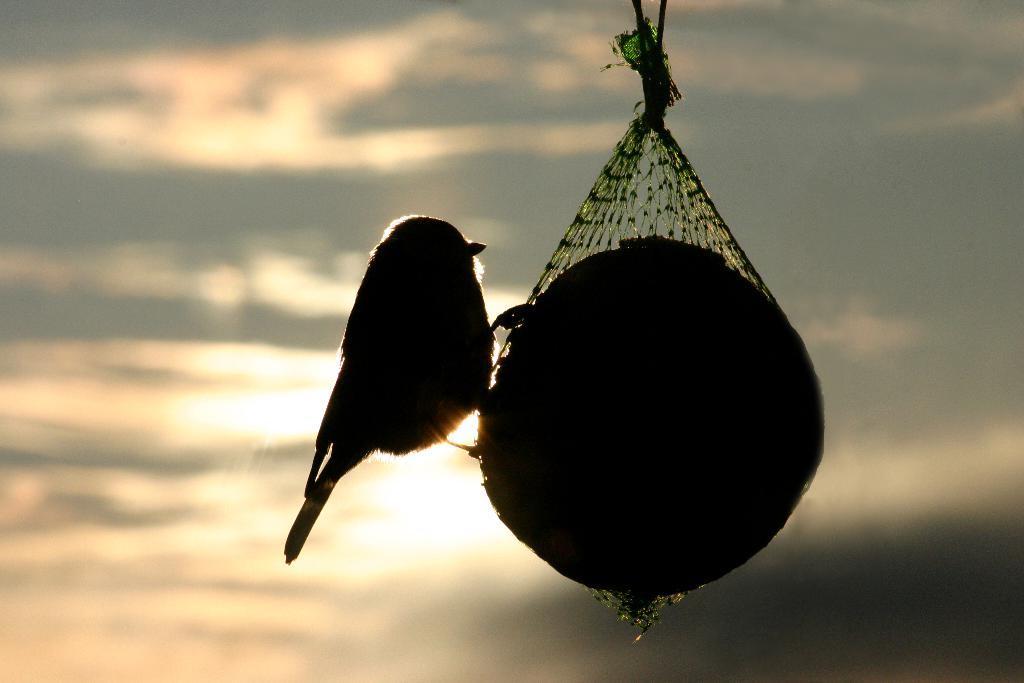Can you describe this image briefly? In this image we can see a bird on a ball which is covered with the net tied with a rope. On the backside we can see the sky which looks cloudy. 